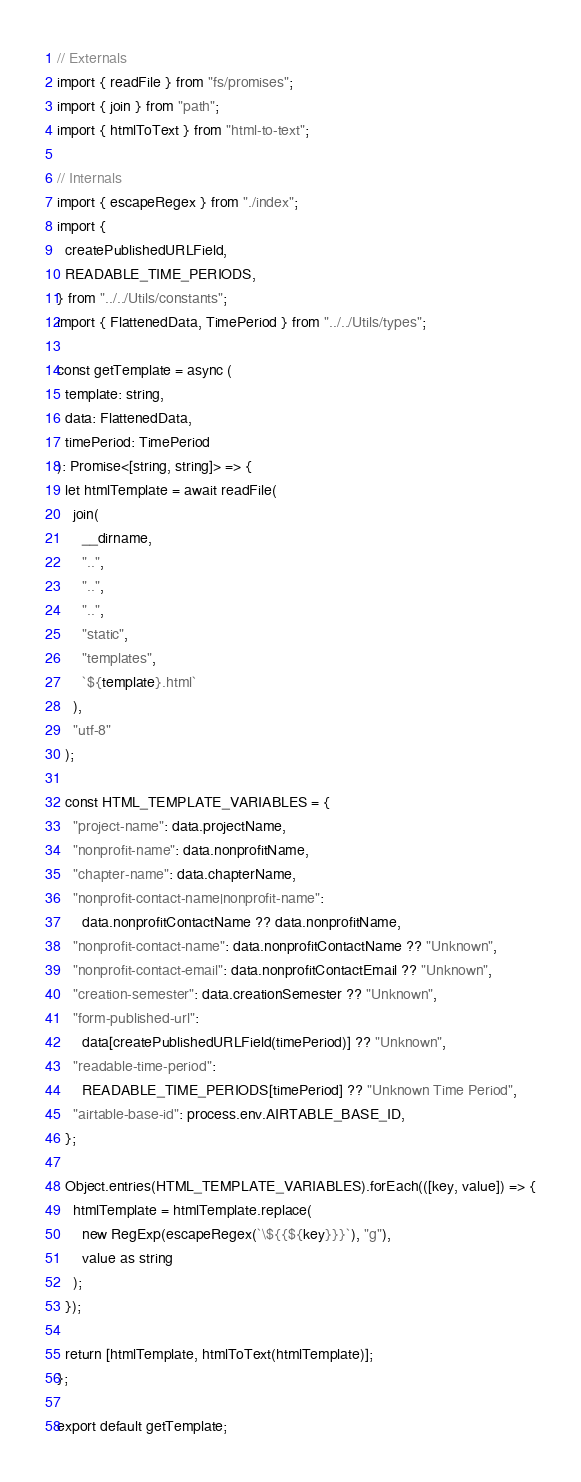<code> <loc_0><loc_0><loc_500><loc_500><_TypeScript_>// Externals
import { readFile } from "fs/promises";
import { join } from "path";
import { htmlToText } from "html-to-text";

// Internals
import { escapeRegex } from "./index";
import {
  createPublishedURLField,
  READABLE_TIME_PERIODS,
} from "../../Utils/constants";
import { FlattenedData, TimePeriod } from "../../Utils/types";

const getTemplate = async (
  template: string,
  data: FlattenedData,
  timePeriod: TimePeriod
): Promise<[string, string]> => {
  let htmlTemplate = await readFile(
    join(
      __dirname,
      "..",
      "..",
      "..",
      "static",
      "templates",
      `${template}.html`
    ),
    "utf-8"
  );

  const HTML_TEMPLATE_VARIABLES = {
    "project-name": data.projectName,
    "nonprofit-name": data.nonprofitName,
    "chapter-name": data.chapterName,
    "nonprofit-contact-name|nonprofit-name":
      data.nonprofitContactName ?? data.nonprofitName,
    "nonprofit-contact-name": data.nonprofitContactName ?? "Unknown",
    "nonprofit-contact-email": data.nonprofitContactEmail ?? "Unknown",
    "creation-semester": data.creationSemester ?? "Unknown",
    "form-published-url":
      data[createPublishedURLField(timePeriod)] ?? "Unknown",
    "readable-time-period":
      READABLE_TIME_PERIODS[timePeriod] ?? "Unknown Time Period",
    "airtable-base-id": process.env.AIRTABLE_BASE_ID,
  };

  Object.entries(HTML_TEMPLATE_VARIABLES).forEach(([key, value]) => {
    htmlTemplate = htmlTemplate.replace(
      new RegExp(escapeRegex(`\${{${key}}}`), "g"),
      value as string
    );
  });

  return [htmlTemplate, htmlToText(htmlTemplate)];
};

export default getTemplate;
</code> 